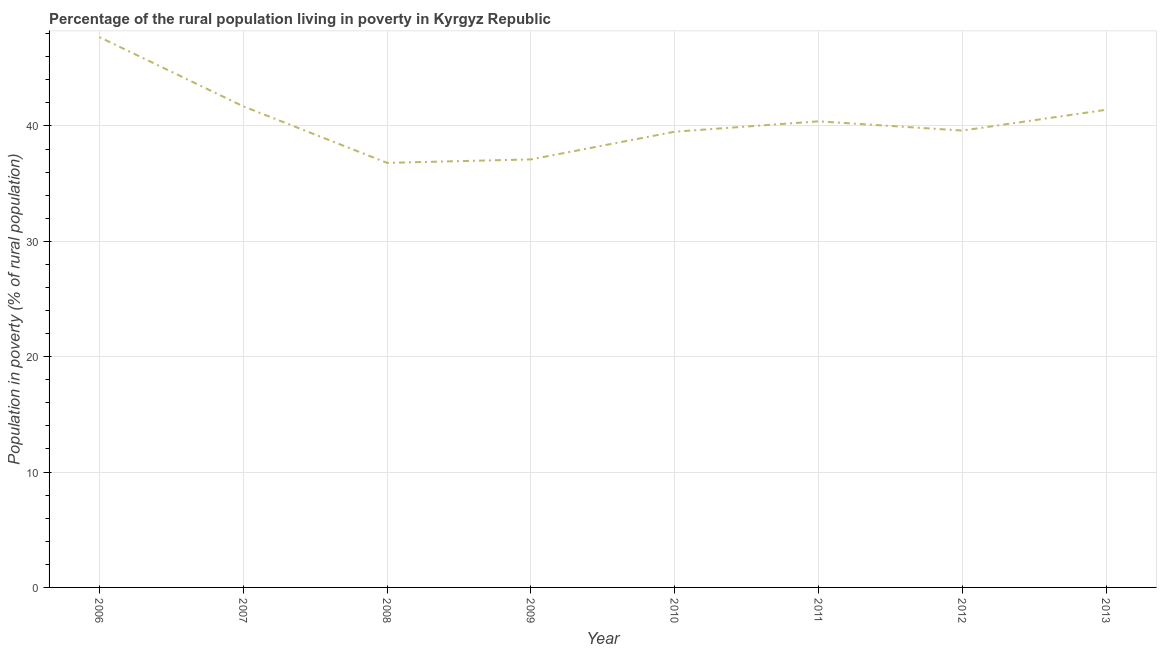What is the percentage of rural population living below poverty line in 2011?
Your answer should be compact. 40.4. Across all years, what is the maximum percentage of rural population living below poverty line?
Offer a terse response. 47.7. Across all years, what is the minimum percentage of rural population living below poverty line?
Your answer should be compact. 36.8. In which year was the percentage of rural population living below poverty line minimum?
Ensure brevity in your answer.  2008. What is the sum of the percentage of rural population living below poverty line?
Your answer should be compact. 324.2. What is the average percentage of rural population living below poverty line per year?
Ensure brevity in your answer.  40.53. What is the median percentage of rural population living below poverty line?
Your answer should be very brief. 40. In how many years, is the percentage of rural population living below poverty line greater than 46 %?
Provide a short and direct response. 1. Do a majority of the years between 2011 and 2008 (inclusive) have percentage of rural population living below poverty line greater than 44 %?
Your answer should be very brief. Yes. What is the ratio of the percentage of rural population living below poverty line in 2008 to that in 2012?
Your response must be concise. 0.93. Is the percentage of rural population living below poverty line in 2012 less than that in 2013?
Your response must be concise. Yes. What is the difference between the highest and the second highest percentage of rural population living below poverty line?
Make the answer very short. 6. Is the sum of the percentage of rural population living below poverty line in 2009 and 2012 greater than the maximum percentage of rural population living below poverty line across all years?
Your answer should be compact. Yes. What is the difference between the highest and the lowest percentage of rural population living below poverty line?
Ensure brevity in your answer.  10.9. In how many years, is the percentage of rural population living below poverty line greater than the average percentage of rural population living below poverty line taken over all years?
Provide a short and direct response. 3. Does the percentage of rural population living below poverty line monotonically increase over the years?
Your answer should be very brief. No. What is the title of the graph?
Ensure brevity in your answer.  Percentage of the rural population living in poverty in Kyrgyz Republic. What is the label or title of the X-axis?
Provide a short and direct response. Year. What is the label or title of the Y-axis?
Offer a very short reply. Population in poverty (% of rural population). What is the Population in poverty (% of rural population) in 2006?
Your response must be concise. 47.7. What is the Population in poverty (% of rural population) of 2007?
Your response must be concise. 41.7. What is the Population in poverty (% of rural population) of 2008?
Give a very brief answer. 36.8. What is the Population in poverty (% of rural population) of 2009?
Your answer should be very brief. 37.1. What is the Population in poverty (% of rural population) in 2010?
Provide a short and direct response. 39.5. What is the Population in poverty (% of rural population) of 2011?
Provide a succinct answer. 40.4. What is the Population in poverty (% of rural population) in 2012?
Give a very brief answer. 39.6. What is the Population in poverty (% of rural population) in 2013?
Offer a terse response. 41.4. What is the difference between the Population in poverty (% of rural population) in 2006 and 2007?
Your answer should be very brief. 6. What is the difference between the Population in poverty (% of rural population) in 2006 and 2008?
Your response must be concise. 10.9. What is the difference between the Population in poverty (% of rural population) in 2006 and 2009?
Your answer should be very brief. 10.6. What is the difference between the Population in poverty (% of rural population) in 2006 and 2010?
Your answer should be compact. 8.2. What is the difference between the Population in poverty (% of rural population) in 2006 and 2011?
Your response must be concise. 7.3. What is the difference between the Population in poverty (% of rural population) in 2007 and 2008?
Give a very brief answer. 4.9. What is the difference between the Population in poverty (% of rural population) in 2007 and 2010?
Provide a succinct answer. 2.2. What is the difference between the Population in poverty (% of rural population) in 2007 and 2011?
Your response must be concise. 1.3. What is the difference between the Population in poverty (% of rural population) in 2007 and 2012?
Offer a very short reply. 2.1. What is the difference between the Population in poverty (% of rural population) in 2008 and 2010?
Give a very brief answer. -2.7. What is the difference between the Population in poverty (% of rural population) in 2008 and 2013?
Keep it short and to the point. -4.6. What is the difference between the Population in poverty (% of rural population) in 2009 and 2011?
Make the answer very short. -3.3. What is the difference between the Population in poverty (% of rural population) in 2009 and 2012?
Offer a very short reply. -2.5. What is the difference between the Population in poverty (% of rural population) in 2009 and 2013?
Keep it short and to the point. -4.3. What is the difference between the Population in poverty (% of rural population) in 2010 and 2013?
Your answer should be compact. -1.9. What is the difference between the Population in poverty (% of rural population) in 2012 and 2013?
Your answer should be very brief. -1.8. What is the ratio of the Population in poverty (% of rural population) in 2006 to that in 2007?
Provide a succinct answer. 1.14. What is the ratio of the Population in poverty (% of rural population) in 2006 to that in 2008?
Your answer should be very brief. 1.3. What is the ratio of the Population in poverty (% of rural population) in 2006 to that in 2009?
Offer a very short reply. 1.29. What is the ratio of the Population in poverty (% of rural population) in 2006 to that in 2010?
Make the answer very short. 1.21. What is the ratio of the Population in poverty (% of rural population) in 2006 to that in 2011?
Your answer should be compact. 1.18. What is the ratio of the Population in poverty (% of rural population) in 2006 to that in 2012?
Provide a short and direct response. 1.21. What is the ratio of the Population in poverty (% of rural population) in 2006 to that in 2013?
Ensure brevity in your answer.  1.15. What is the ratio of the Population in poverty (% of rural population) in 2007 to that in 2008?
Provide a succinct answer. 1.13. What is the ratio of the Population in poverty (% of rural population) in 2007 to that in 2009?
Provide a short and direct response. 1.12. What is the ratio of the Population in poverty (% of rural population) in 2007 to that in 2010?
Ensure brevity in your answer.  1.06. What is the ratio of the Population in poverty (% of rural population) in 2007 to that in 2011?
Offer a terse response. 1.03. What is the ratio of the Population in poverty (% of rural population) in 2007 to that in 2012?
Offer a very short reply. 1.05. What is the ratio of the Population in poverty (% of rural population) in 2008 to that in 2010?
Provide a short and direct response. 0.93. What is the ratio of the Population in poverty (% of rural population) in 2008 to that in 2011?
Your answer should be compact. 0.91. What is the ratio of the Population in poverty (% of rural population) in 2008 to that in 2012?
Ensure brevity in your answer.  0.93. What is the ratio of the Population in poverty (% of rural population) in 2008 to that in 2013?
Ensure brevity in your answer.  0.89. What is the ratio of the Population in poverty (% of rural population) in 2009 to that in 2010?
Provide a succinct answer. 0.94. What is the ratio of the Population in poverty (% of rural population) in 2009 to that in 2011?
Provide a short and direct response. 0.92. What is the ratio of the Population in poverty (% of rural population) in 2009 to that in 2012?
Keep it short and to the point. 0.94. What is the ratio of the Population in poverty (% of rural population) in 2009 to that in 2013?
Provide a succinct answer. 0.9. What is the ratio of the Population in poverty (% of rural population) in 2010 to that in 2011?
Offer a very short reply. 0.98. What is the ratio of the Population in poverty (% of rural population) in 2010 to that in 2012?
Give a very brief answer. 1. What is the ratio of the Population in poverty (% of rural population) in 2010 to that in 2013?
Offer a terse response. 0.95. 